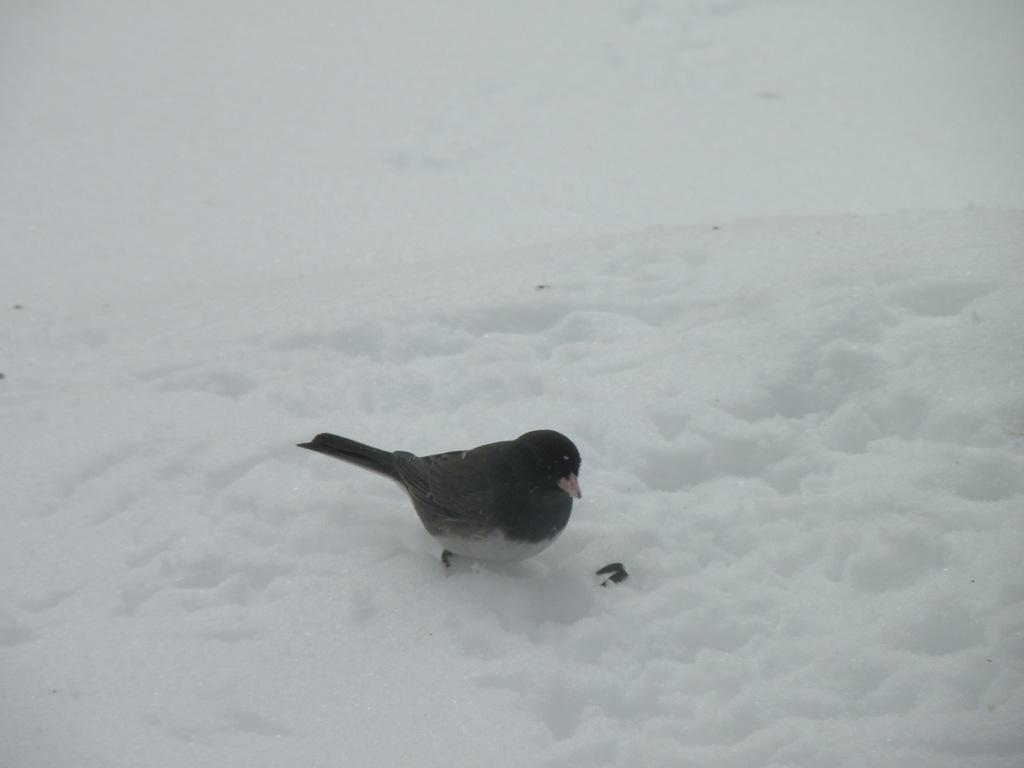What type of bird can be seen in the image? There is a black bird in the image. What is the color of the snow in the image? There is white snow in the image. Can you describe the black object in the image? There is a black object in the image, but its specific nature cannot be determined from the provided facts. How many horses can be seen grazing in the snow in the image? There are no horses present in the image; it features a black bird and white snow. What type of beetle can be seen crawling on the black object in the image? There is no beetle present in the image, and the nature of the black object cannot be determined from the provided facts. 